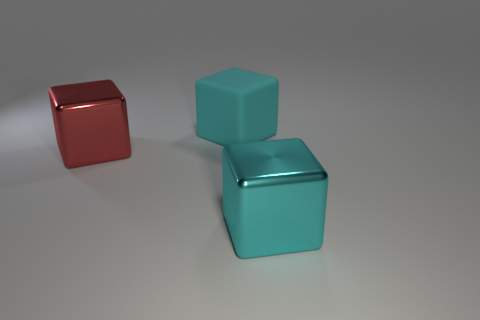Add 3 large cyan objects. How many objects exist? 6 Add 2 red shiny objects. How many red shiny objects are left? 3 Add 1 big cyan metal cubes. How many big cyan metal cubes exist? 2 Subtract 0 yellow balls. How many objects are left? 3 Subtract all brown shiny balls. Subtract all large cyan objects. How many objects are left? 1 